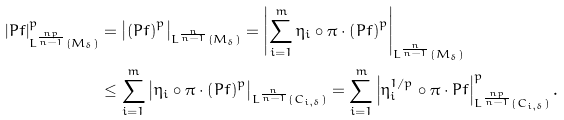<formula> <loc_0><loc_0><loc_500><loc_500>\left | P f \right | _ { L ^ { \frac { n p } { n - 1 } } \left ( M _ { \delta } \right ) } ^ { p } & = \left | \left ( P f \right ) ^ { p } \right | _ { L ^ { \frac { n } { n - 1 } } \left ( M _ { \delta } \right ) } = \left | \sum _ { i = 1 } ^ { m } \eta _ { i } \circ \pi \cdot \left ( P f \right ) ^ { p } \right | _ { L ^ { \frac { n } { n - 1 } } \left ( M _ { \delta } \right ) } \\ & \leq \sum _ { i = 1 } ^ { m } \left | \eta _ { i } \circ \pi \cdot \left ( P f \right ) ^ { p } \right | _ { L ^ { \frac { n } { n - 1 } } \left ( C _ { i , \delta } \right ) } = \sum _ { i = 1 } ^ { m } \left | \eta _ { i } ^ { 1 / p } \circ \pi \cdot P f \right | _ { L ^ { \frac { n p } { n - 1 } } \left ( C _ { i , \delta } \right ) } ^ { p } .</formula> 